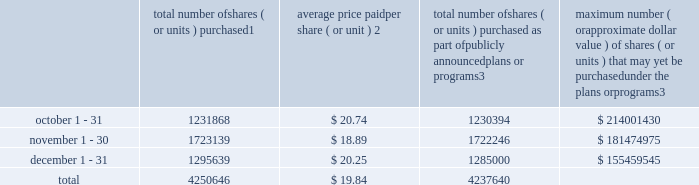Sales of unregistered securities not applicable .
Repurchases of equity securities the table provides information regarding our purchases of our equity securities during the period from october 1 , 2017 to december 31 , 2017 .
Total number of shares ( or units ) purchased 1 average price paid per share ( or unit ) 2 total number of shares ( or units ) purchased as part of publicly announced plans or programs 3 maximum number ( or approximate dollar value ) of shares ( or units ) that may yet be purchased under the plans or programs 3 .
1 included shares of our common stock , par value $ 0.10 per share , withheld under the terms of grants under employee stock-based compensation plans to offset tax withholding obligations that occurred upon vesting and release of restricted shares ( the 201cwithheld shares 201d ) .
We repurchased 1474 withheld shares in october 2017 , 893 withheld shares in november 2017 and 10639 withheld shares in december 2017 , for a total of 13006 withheld shares during the three-month period .
2 the average price per share for each of the months in the fiscal quarter and for the three-month period was calculated by dividing the sum of the applicable period of the aggregate value of the tax withholding obligations and the aggregate amount we paid for shares acquired under our share repurchase program , described in note 5 to the consolidated financial statements , by the sum of the number of withheld shares and the number of shares acquired in our share repurchase program .
3 in february 2017 , the board authorized a share repurchase program to repurchase from time to time up to $ 300.0 million , excluding fees , of our common stock ( the 201c2017 share repurchase program 201d ) .
On february 14 , 2018 , we announced that our board had approved a new share repurchase program to repurchase from time to time up to $ 300.0 million , excluding fees , of our common stock .
The new authorization is in addition to any amounts remaining for repurchase under the 2017 share repurchase program .
There is no expiration date associated with the share repurchase programs. .
What is the percentage decrease in average price per share from october to november? 
Computations: (((20.74 - 18.89) / 20.74) * 100)
Answer: 8.91996. Sales of unregistered securities not applicable .
Repurchases of equity securities the table provides information regarding our purchases of our equity securities during the period from october 1 , 2017 to december 31 , 2017 .
Total number of shares ( or units ) purchased 1 average price paid per share ( or unit ) 2 total number of shares ( or units ) purchased as part of publicly announced plans or programs 3 maximum number ( or approximate dollar value ) of shares ( or units ) that may yet be purchased under the plans or programs 3 .
1 included shares of our common stock , par value $ 0.10 per share , withheld under the terms of grants under employee stock-based compensation plans to offset tax withholding obligations that occurred upon vesting and release of restricted shares ( the 201cwithheld shares 201d ) .
We repurchased 1474 withheld shares in october 2017 , 893 withheld shares in november 2017 and 10639 withheld shares in december 2017 , for a total of 13006 withheld shares during the three-month period .
2 the average price per share for each of the months in the fiscal quarter and for the three-month period was calculated by dividing the sum of the applicable period of the aggregate value of the tax withholding obligations and the aggregate amount we paid for shares acquired under our share repurchase program , described in note 5 to the consolidated financial statements , by the sum of the number of withheld shares and the number of shares acquired in our share repurchase program .
3 in february 2017 , the board authorized a share repurchase program to repurchase from time to time up to $ 300.0 million , excluding fees , of our common stock ( the 201c2017 share repurchase program 201d ) .
On february 14 , 2018 , we announced that our board had approved a new share repurchase program to repurchase from time to time up to $ 300.0 million , excluding fees , of our common stock .
The new authorization is in addition to any amounts remaining for repurchase under the 2017 share repurchase program .
There is no expiration date associated with the share repurchase programs. .
What is the monthly average of withheld shares from october to december 2017? 
Computations: (((1474 + 893) + 10639) / 3)
Answer: 4335.33333. 